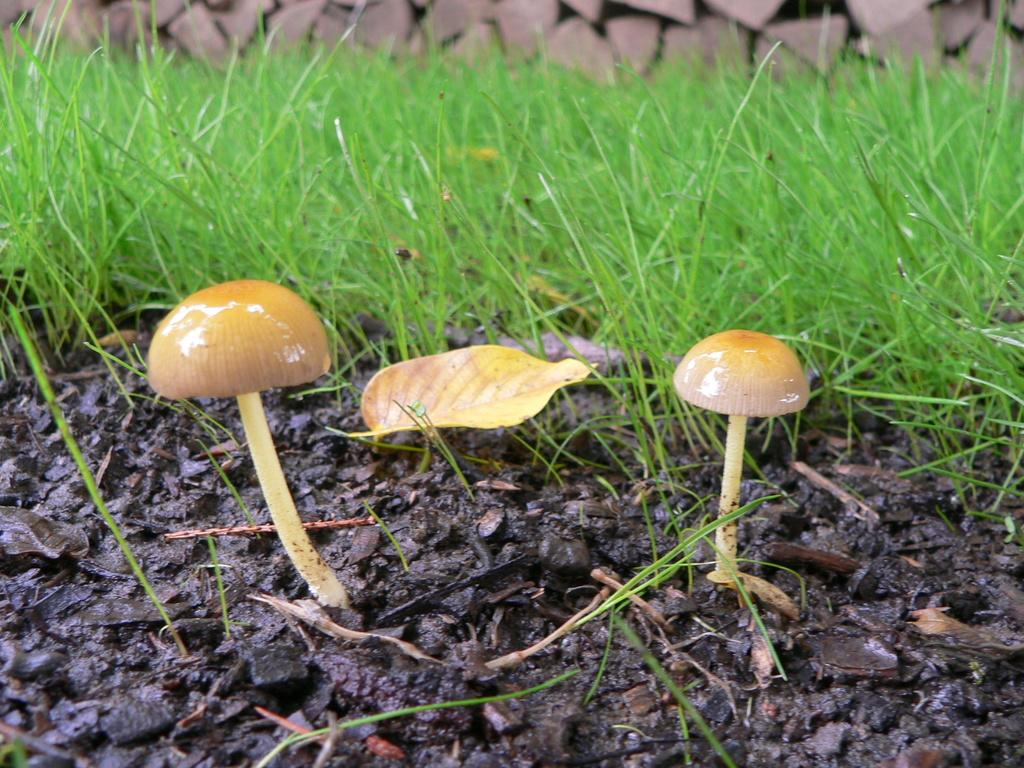How many mushrooms can be seen in the image? There are two mushrooms in the image. What type of vegetation is present on the ground in the image? There is grass on the ground in the image. What type of natural feature can be seen at the top of the image? There are rocks visible at the top of the image. Is there a fireman with a pocket full of legos in the image? No, there is no fireman or legos present in the image. 